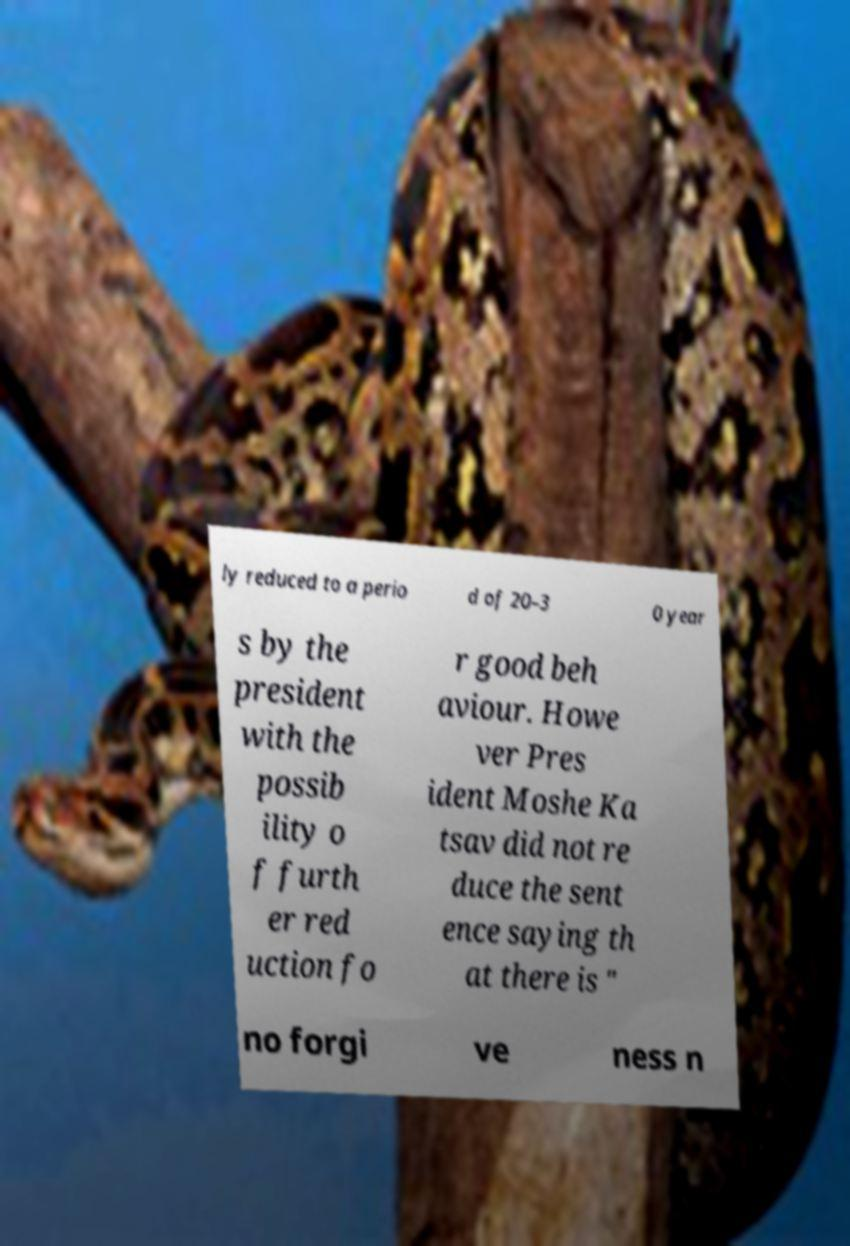Could you extract and type out the text from this image? ly reduced to a perio d of 20–3 0 year s by the president with the possib ility o f furth er red uction fo r good beh aviour. Howe ver Pres ident Moshe Ka tsav did not re duce the sent ence saying th at there is " no forgi ve ness n 